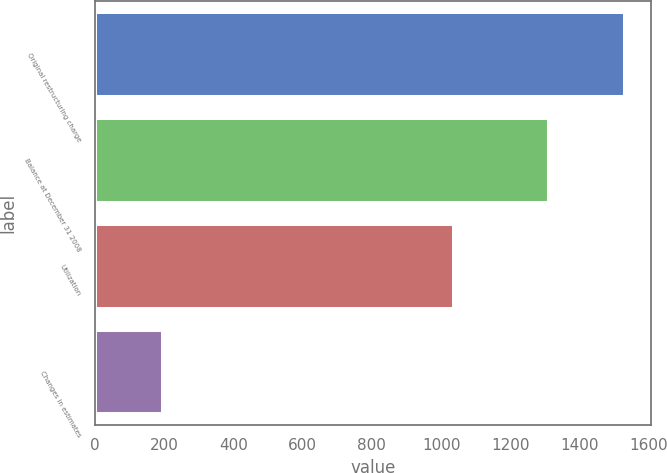Convert chart. <chart><loc_0><loc_0><loc_500><loc_500><bar_chart><fcel>Original restructuring charge<fcel>Balance at December 31 2008<fcel>Utilization<fcel>Changes in estimates<nl><fcel>1530<fcel>1311<fcel>1037<fcel>196<nl></chart> 